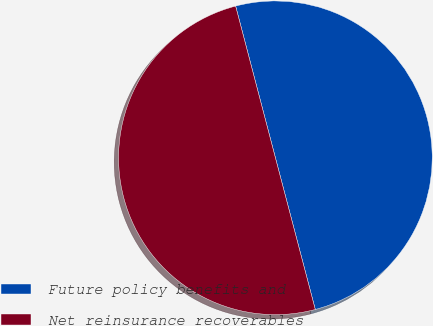Convert chart to OTSL. <chart><loc_0><loc_0><loc_500><loc_500><pie_chart><fcel>Future policy benefits and<fcel>Net reinsurance recoverables<nl><fcel>49.99%<fcel>50.01%<nl></chart> 